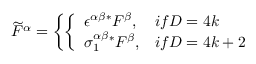<formula> <loc_0><loc_0><loc_500><loc_500>\widetilde { F } ^ { \alpha } = \left \{ \left \{ \begin{array} { l l } { { \epsilon ^ { \alpha \beta } ^ { * } F ^ { \beta } , } } & { i f D = 4 k } \\ { { \sigma _ { 1 } ^ { \alpha \beta } ^ { * } F ^ { \beta } , } } & { i f D = 4 k + 2 } \end{array}</formula> 